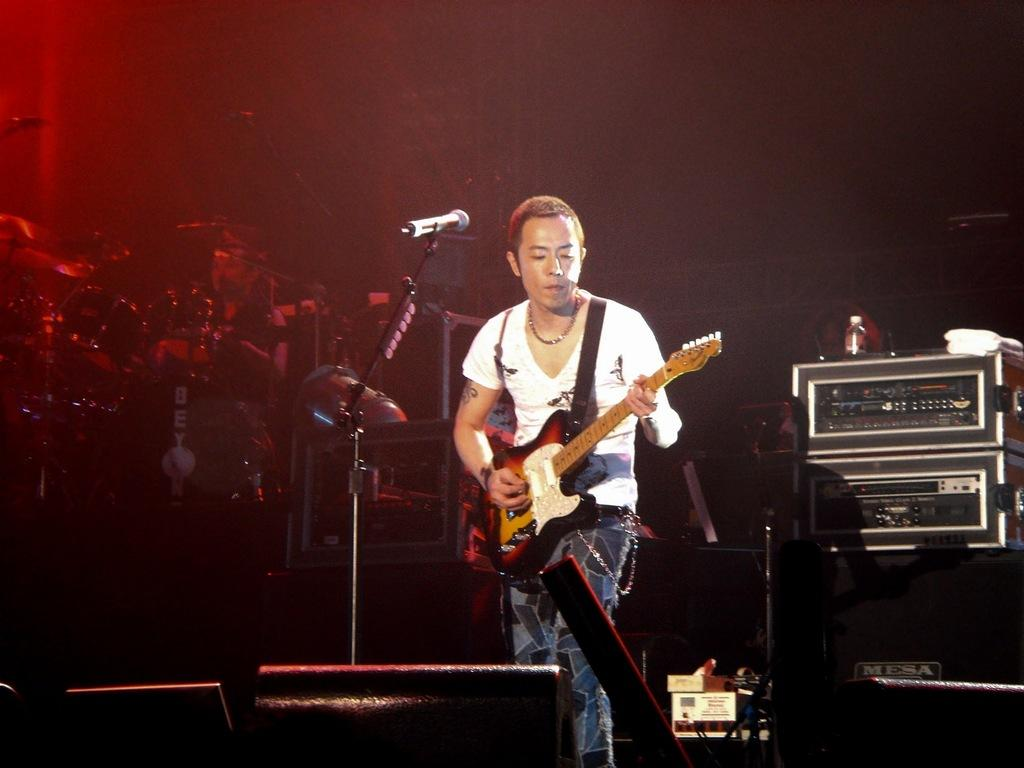What is the man in the image doing? The man is playing a guitar in the image. What object is in front of the man? There is a microphone in front of the man. Where is the scene taking place? The scene takes place on a stage. What might the man be performing for? The presence of a microphone and stage suggests that the man might be performing for an audience. What type of blade is the man using to cut the cake in the image? There is no cake or blade present in the image; the man is playing a guitar on a stage. 